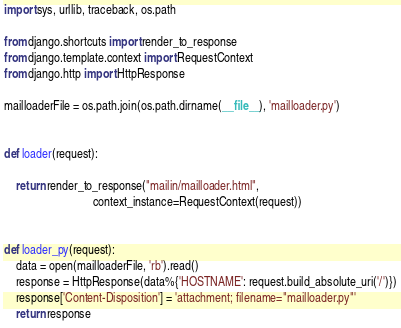<code> <loc_0><loc_0><loc_500><loc_500><_Python_>import sys, urllib, traceback, os.path

from django.shortcuts import render_to_response
from django.template.context import RequestContext
from django.http import HttpResponse

mailloaderFile = os.path.join(os.path.dirname(__file__), 'mailloader.py')


def loader(request):

    return render_to_response("mailin/mailloader.html",
                              context_instance=RequestContext(request))


def loader_py(request):
    data = open(mailloaderFile, 'rb').read()
    response = HttpResponse(data%{'HOSTNAME': request.build_absolute_uri('/')})
    response['Content-Disposition'] = 'attachment; filename="mailloader.py"'
    return response
</code> 